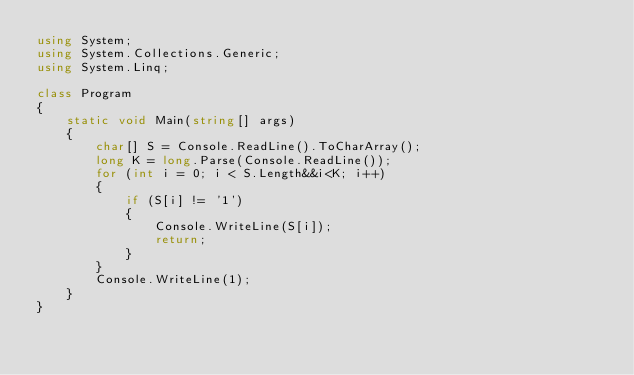<code> <loc_0><loc_0><loc_500><loc_500><_C#_>using System;
using System.Collections.Generic;
using System.Linq;

class Program
{
    static void Main(string[] args)
    {
        char[] S = Console.ReadLine().ToCharArray();
        long K = long.Parse(Console.ReadLine());
        for (int i = 0; i < S.Length&&i<K; i++)
        {
            if (S[i] != '1')
            {
                Console.WriteLine(S[i]);
                return;
            }
        }
        Console.WriteLine(1);
    }
}
</code> 